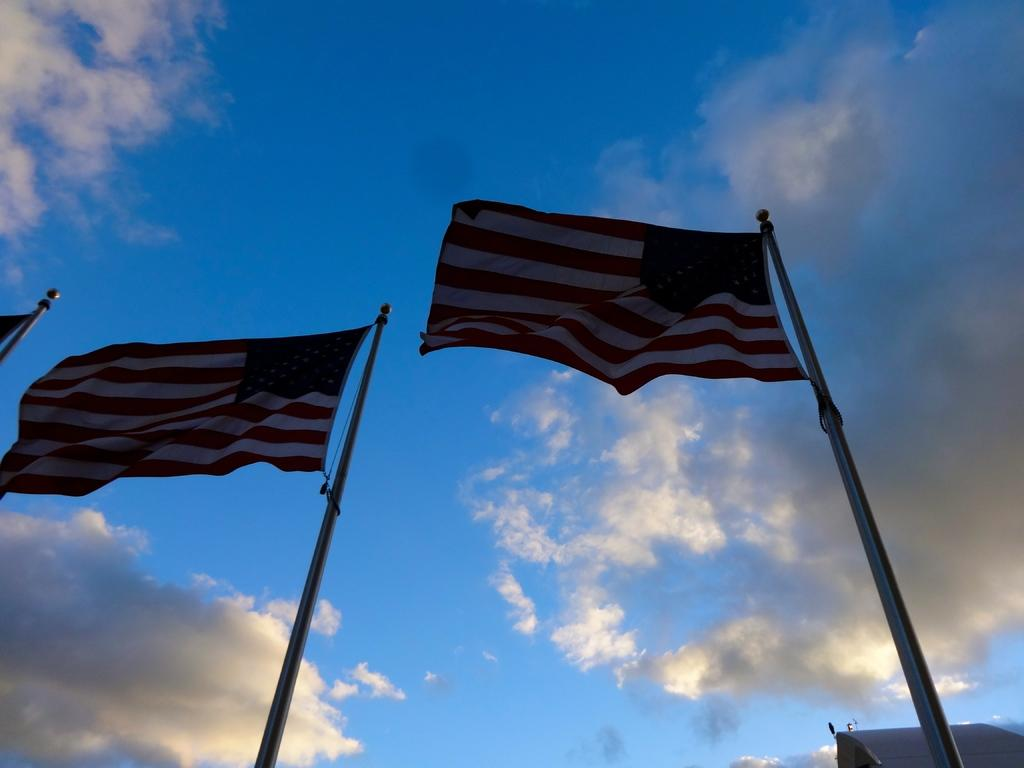What can be seen in the image that represents national or cultural symbols? There are flags in the image. What are the flags attached to in the image? There are poles in the image. What can be seen in the background of the image? The sky is visible in the background of the image. What is located on the right side of the image? There is an object on the right side of the image. What type of hall can be seen in the aftermath of the event in the image? There is no hall or event present in the image; it only features flags, poles, and the sky. 